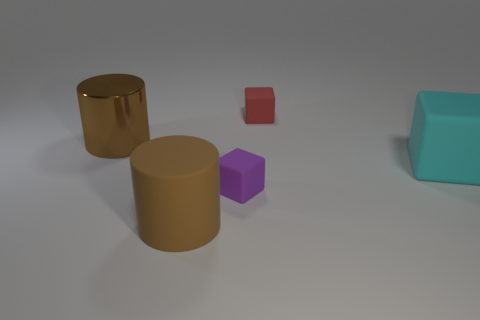Subtract 2 cylinders. How many cylinders are left? 0 Add 5 tiny purple things. How many objects exist? 10 Subtract all cyan rubber blocks. How many blocks are left? 2 Subtract all small matte things. Subtract all big brown metallic objects. How many objects are left? 2 Add 3 red objects. How many red objects are left? 4 Add 3 small blue matte cylinders. How many small blue matte cylinders exist? 3 Subtract 0 brown cubes. How many objects are left? 5 Subtract all cubes. How many objects are left? 2 Subtract all gray cylinders. Subtract all purple balls. How many cylinders are left? 2 Subtract all purple cubes. How many yellow cylinders are left? 0 